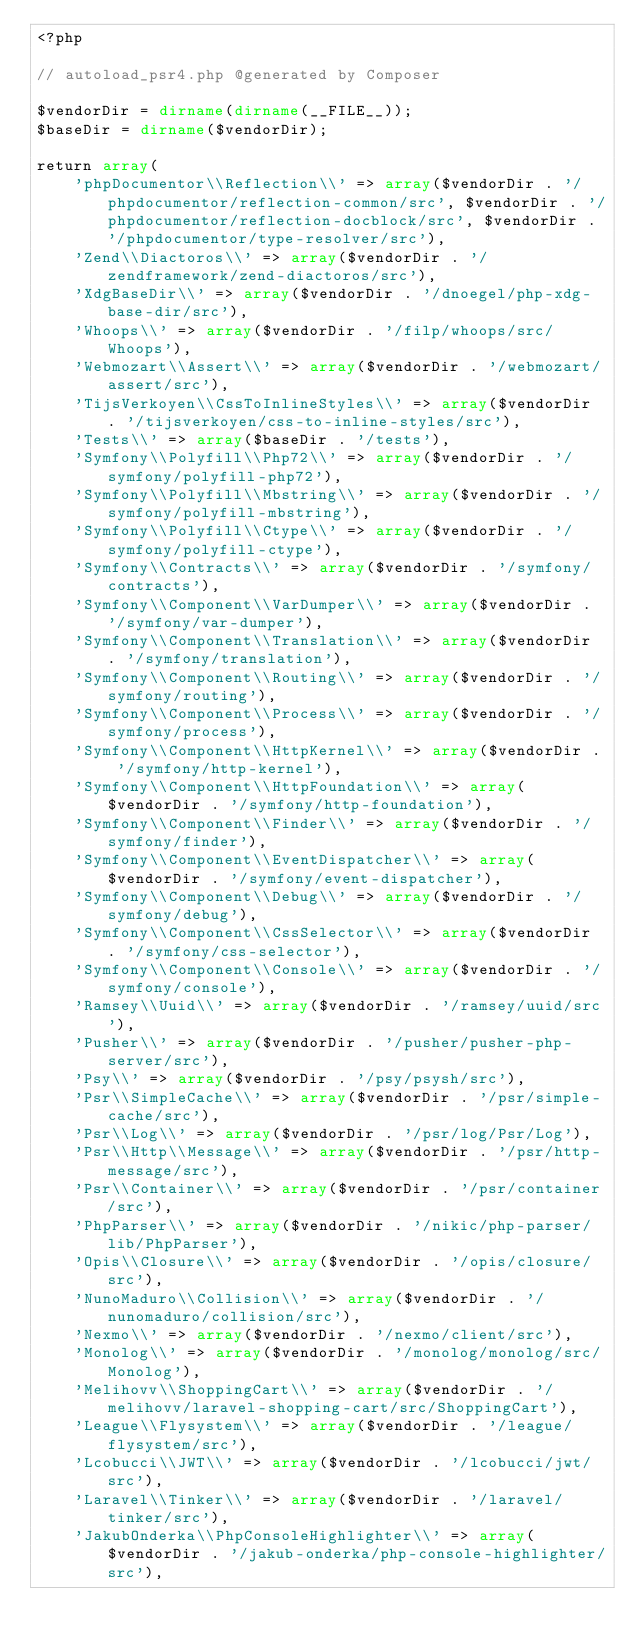Convert code to text. <code><loc_0><loc_0><loc_500><loc_500><_PHP_><?php

// autoload_psr4.php @generated by Composer

$vendorDir = dirname(dirname(__FILE__));
$baseDir = dirname($vendorDir);

return array(
    'phpDocumentor\\Reflection\\' => array($vendorDir . '/phpdocumentor/reflection-common/src', $vendorDir . '/phpdocumentor/reflection-docblock/src', $vendorDir . '/phpdocumentor/type-resolver/src'),
    'Zend\\Diactoros\\' => array($vendorDir . '/zendframework/zend-diactoros/src'),
    'XdgBaseDir\\' => array($vendorDir . '/dnoegel/php-xdg-base-dir/src'),
    'Whoops\\' => array($vendorDir . '/filp/whoops/src/Whoops'),
    'Webmozart\\Assert\\' => array($vendorDir . '/webmozart/assert/src'),
    'TijsVerkoyen\\CssToInlineStyles\\' => array($vendorDir . '/tijsverkoyen/css-to-inline-styles/src'),
    'Tests\\' => array($baseDir . '/tests'),
    'Symfony\\Polyfill\\Php72\\' => array($vendorDir . '/symfony/polyfill-php72'),
    'Symfony\\Polyfill\\Mbstring\\' => array($vendorDir . '/symfony/polyfill-mbstring'),
    'Symfony\\Polyfill\\Ctype\\' => array($vendorDir . '/symfony/polyfill-ctype'),
    'Symfony\\Contracts\\' => array($vendorDir . '/symfony/contracts'),
    'Symfony\\Component\\VarDumper\\' => array($vendorDir . '/symfony/var-dumper'),
    'Symfony\\Component\\Translation\\' => array($vendorDir . '/symfony/translation'),
    'Symfony\\Component\\Routing\\' => array($vendorDir . '/symfony/routing'),
    'Symfony\\Component\\Process\\' => array($vendorDir . '/symfony/process'),
    'Symfony\\Component\\HttpKernel\\' => array($vendorDir . '/symfony/http-kernel'),
    'Symfony\\Component\\HttpFoundation\\' => array($vendorDir . '/symfony/http-foundation'),
    'Symfony\\Component\\Finder\\' => array($vendorDir . '/symfony/finder'),
    'Symfony\\Component\\EventDispatcher\\' => array($vendorDir . '/symfony/event-dispatcher'),
    'Symfony\\Component\\Debug\\' => array($vendorDir . '/symfony/debug'),
    'Symfony\\Component\\CssSelector\\' => array($vendorDir . '/symfony/css-selector'),
    'Symfony\\Component\\Console\\' => array($vendorDir . '/symfony/console'),
    'Ramsey\\Uuid\\' => array($vendorDir . '/ramsey/uuid/src'),
    'Pusher\\' => array($vendorDir . '/pusher/pusher-php-server/src'),
    'Psy\\' => array($vendorDir . '/psy/psysh/src'),
    'Psr\\SimpleCache\\' => array($vendorDir . '/psr/simple-cache/src'),
    'Psr\\Log\\' => array($vendorDir . '/psr/log/Psr/Log'),
    'Psr\\Http\\Message\\' => array($vendorDir . '/psr/http-message/src'),
    'Psr\\Container\\' => array($vendorDir . '/psr/container/src'),
    'PhpParser\\' => array($vendorDir . '/nikic/php-parser/lib/PhpParser'),
    'Opis\\Closure\\' => array($vendorDir . '/opis/closure/src'),
    'NunoMaduro\\Collision\\' => array($vendorDir . '/nunomaduro/collision/src'),
    'Nexmo\\' => array($vendorDir . '/nexmo/client/src'),
    'Monolog\\' => array($vendorDir . '/monolog/monolog/src/Monolog'),
    'Melihovv\\ShoppingCart\\' => array($vendorDir . '/melihovv/laravel-shopping-cart/src/ShoppingCart'),
    'League\\Flysystem\\' => array($vendorDir . '/league/flysystem/src'),
    'Lcobucci\\JWT\\' => array($vendorDir . '/lcobucci/jwt/src'),
    'Laravel\\Tinker\\' => array($vendorDir . '/laravel/tinker/src'),
    'JakubOnderka\\PhpConsoleHighlighter\\' => array($vendorDir . '/jakub-onderka/php-console-highlighter/src'),</code> 